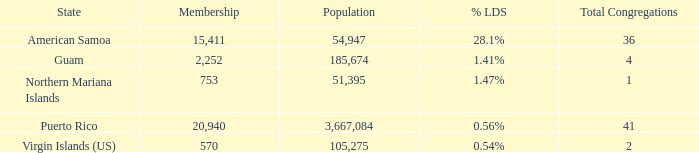What is the highest Population, when % LDS is 0.54%, and when Total Congregations is greater than 2? None. 